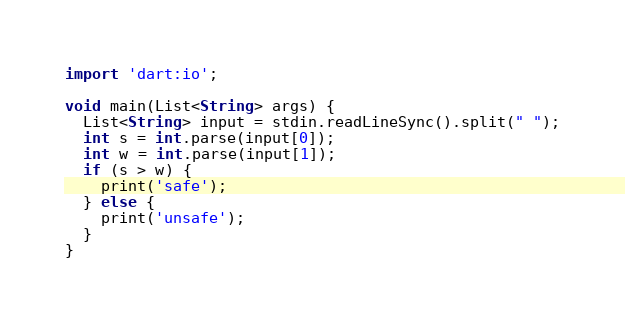<code> <loc_0><loc_0><loc_500><loc_500><_Dart_>import 'dart:io';

void main(List<String> args) {
  List<String> input = stdin.readLineSync().split(" ");
  int s = int.parse(input[0]);
  int w = int.parse(input[1]);
  if (s > w) {
  	print('safe');
  } else {
  	print('unsafe');
  }
}</code> 